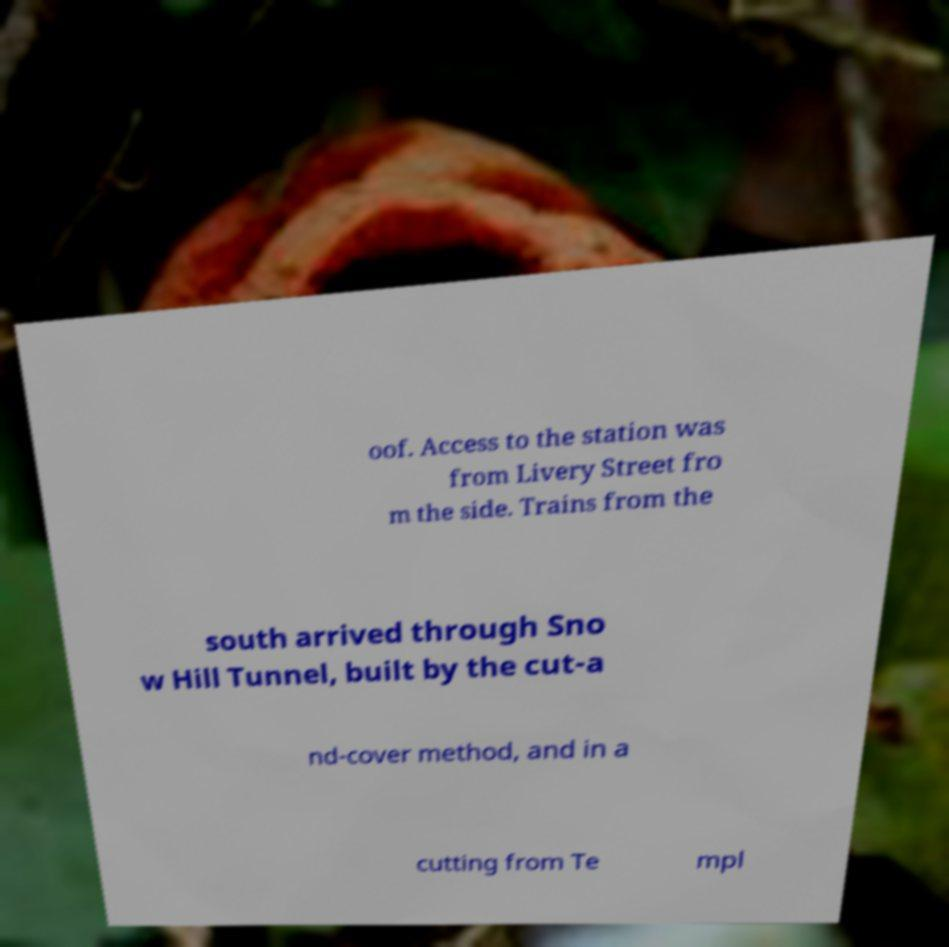Please read and relay the text visible in this image. What does it say? oof. Access to the station was from Livery Street fro m the side. Trains from the south arrived through Sno w Hill Tunnel, built by the cut-a nd-cover method, and in a cutting from Te mpl 